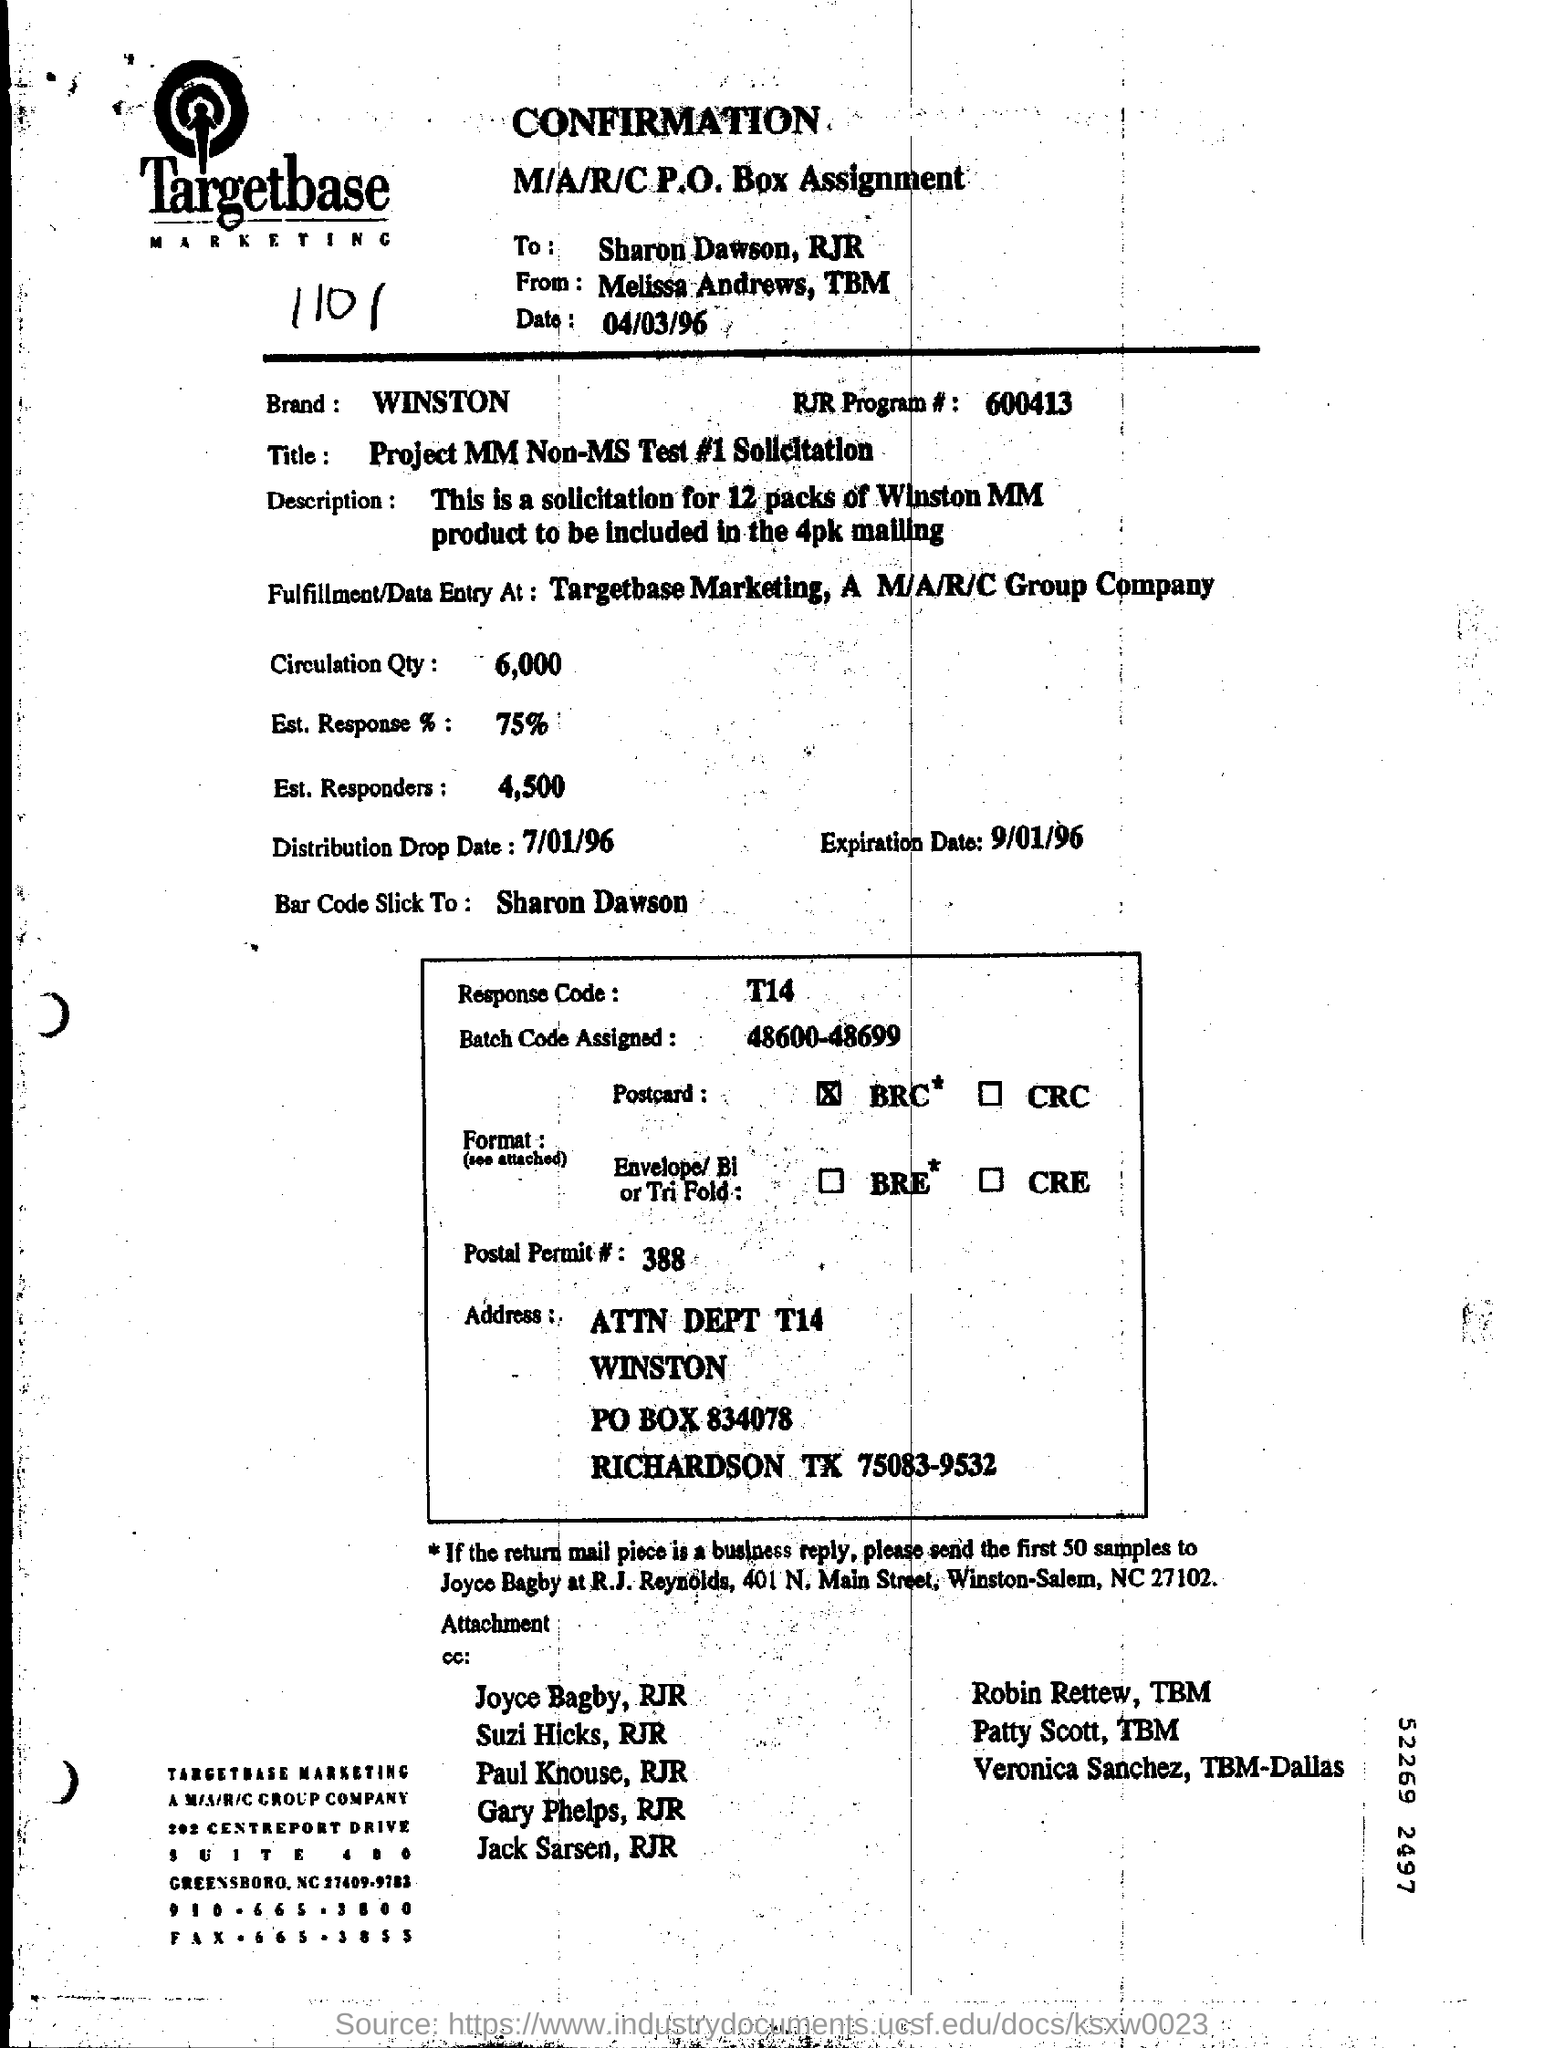Specify some key components in this picture. The response code mentioned in the box is T14. The document is addressed to Sharon Dawson of RJR. The distribution drop date is July 1, 1996. The document was written by Melissa Andrews and TBM. 